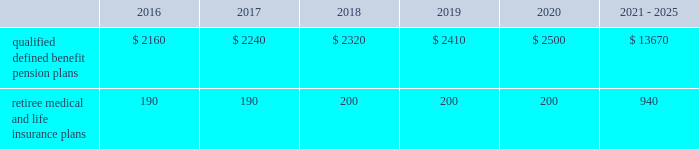Contributions and expected benefit payments the funding of our qualified defined benefit pension plans is determined in accordance with erisa , as amended by the ppa , and in a manner consistent with cas and internal revenue code rules .
In 2015 , we made $ 5 million in contributions to our new sikorsky bargained qualified defined benefit pension plan and we plan to make approximately $ 25 million in contributions to this plan in 2016 .
The table presents estimated future benefit payments , which reflect expected future employee service , as of december 31 , 2015 ( in millions ) : .
Defined contribution plans we maintain a number of defined contribution plans , most with 401 ( k ) features , that cover substantially all of our employees .
Under the provisions of our 401 ( k ) plans , we match most employees 2019 eligible contributions at rates specified in the plan documents .
Our contributions were $ 393 million in 2015 , $ 385 million in 2014 and $ 383 million in 2013 , the majority of which were funded in our common stock .
Our defined contribution plans held approximately 40.0 million and 41.7 million shares of our common stock as of december 31 , 2015 and 2014 .
Note 12 2013 stockholders 2019 equity at december 31 , 2015 and 2014 , our authorized capital was composed of 1.5 billion shares of common stock and 50 million shares of series preferred stock .
Of the 305 million shares of common stock issued and outstanding as of december 31 , 2015 , 303 million shares were considered outstanding for balance sheet presentation purposes ; the remaining shares were held in a separate trust .
Of the 316 million shares of common stock issued and outstanding as of december 31 , 2014 , 314 million shares were considered outstanding for balance sheet presentation purposes ; the remaining shares were held in a separate trust .
No shares of preferred stock were issued and outstanding at december 31 , 2015 or 2014 .
Repurchases of common stock during 2015 , we repurchased 15.2 million shares of our common stock for $ 3.1 billion .
During 2014 and 2013 , we paid $ 1.9 billion and $ 1.8 billion to repurchase 11.5 million and 16.2 million shares of our common stock .
On september 24 , 2015 , our board of directors approved a $ 3.0 billion increase to our share repurchase program .
Inclusive of this increase , the total remaining authorization for future common share repurchases under our program was $ 3.6 billion as of december 31 , 2015 .
As we repurchase our common shares , we reduce common stock for the $ 1 of par value of the shares repurchased , with the excess purchase price over par value recorded as a reduction of additional paid-in capital .
Due to the volume of repurchases made under our share repurchase program , additional paid-in capital was reduced to zero , with the remainder of the excess purchase price over par value of $ 2.4 billion and $ 1.1 billion recorded as a reduction of retained earnings in 2015 and 2014 .
We paid dividends totaling $ 1.9 billion ( $ 6.15 per share ) in 2015 , $ 1.8 billion ( $ 5.49 per share ) in 2014 and $ 1.5 billion ( $ 4.78 per share ) in 2013 .
We have increased our quarterly dividend rate in each of the last three years , including a 10% ( 10 % ) increase in the quarterly dividend rate in the fourth quarter of 2015 .
We declared quarterly dividends of $ 1.50 per share during each of the first three quarters of 2015 and $ 1.65 per share during the fourth quarter of 2015 ; $ 1.33 per share during each of the first three quarters of 2014 and $ 1.50 per share during the fourth quarter of 2014 ; and $ 1.15 per share during each of the first three quarters of 2013 and $ 1.33 per share during the fourth quarter of 2013. .
As of december 2015 what was the ratio of the estimated future benefit payments due in 2016 compared to after 2021? 
Computations: (2160 / 13670)
Answer: 0.15801. 